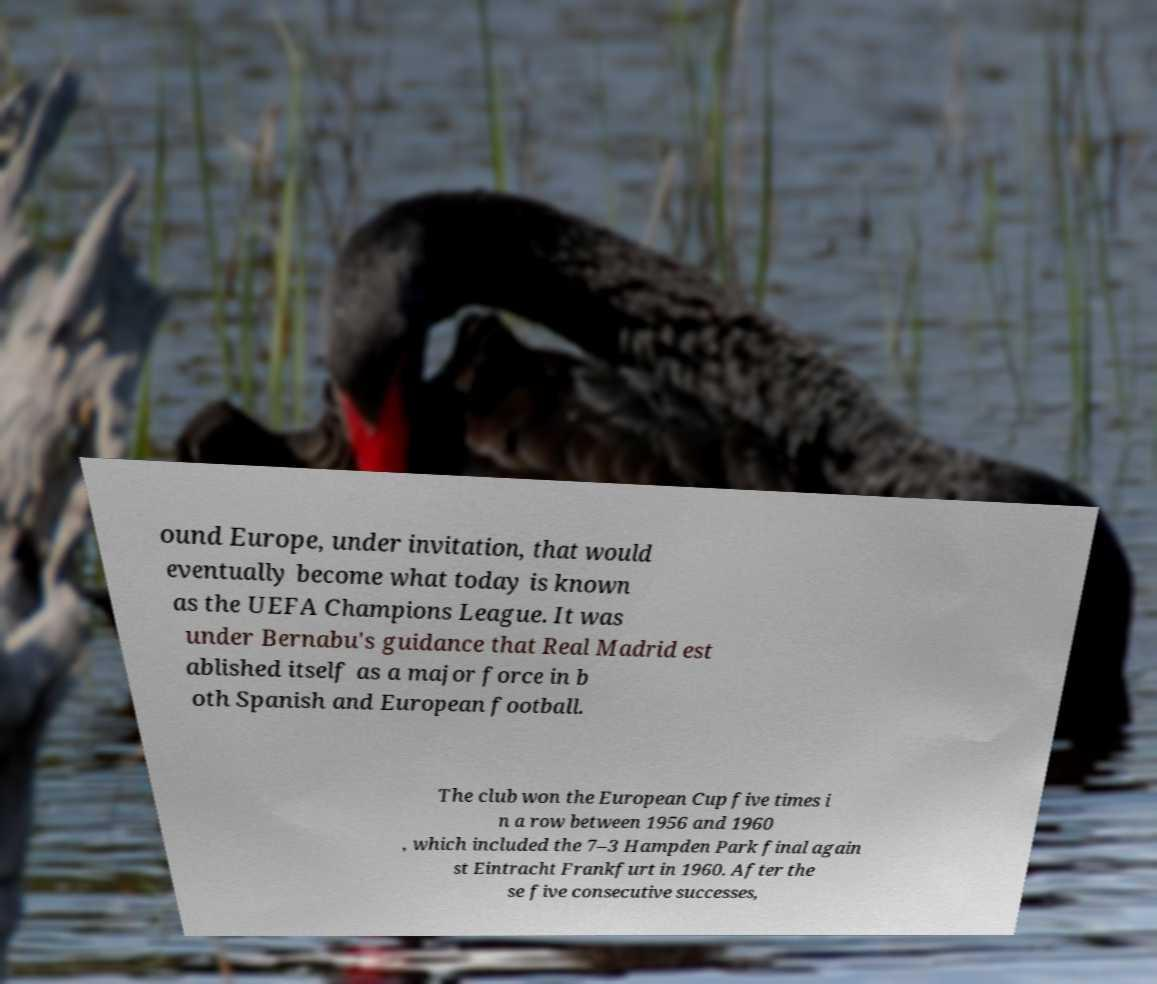What messages or text are displayed in this image? I need them in a readable, typed format. ound Europe, under invitation, that would eventually become what today is known as the UEFA Champions League. It was under Bernabu's guidance that Real Madrid est ablished itself as a major force in b oth Spanish and European football. The club won the European Cup five times i n a row between 1956 and 1960 , which included the 7–3 Hampden Park final again st Eintracht Frankfurt in 1960. After the se five consecutive successes, 